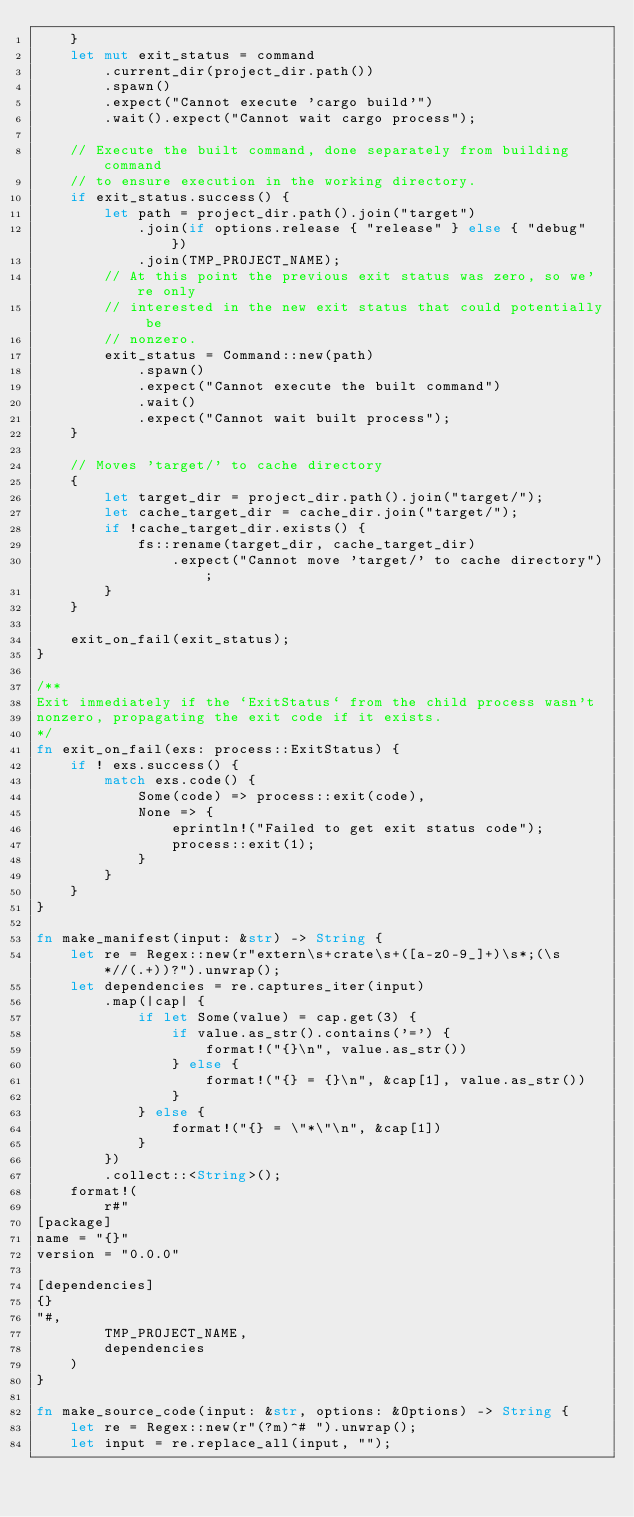Convert code to text. <code><loc_0><loc_0><loc_500><loc_500><_Rust_>    }
    let mut exit_status = command
        .current_dir(project_dir.path())
        .spawn()
        .expect("Cannot execute 'cargo build'")
        .wait().expect("Cannot wait cargo process");

    // Execute the built command, done separately from building command
    // to ensure execution in the working directory.
    if exit_status.success() {
        let path = project_dir.path().join("target")
            .join(if options.release { "release" } else { "debug" })
            .join(TMP_PROJECT_NAME);
        // At this point the previous exit status was zero, so we're only
        // interested in the new exit status that could potentially be
        // nonzero.
        exit_status = Command::new(path)
            .spawn()
            .expect("Cannot execute the built command")
            .wait()
            .expect("Cannot wait built process");
    }

    // Moves 'target/' to cache directory
    {
        let target_dir = project_dir.path().join("target/");
        let cache_target_dir = cache_dir.join("target/");
        if !cache_target_dir.exists() {
            fs::rename(target_dir, cache_target_dir)
                .expect("Cannot move 'target/' to cache directory");
        }
    }

    exit_on_fail(exit_status);
}

/**
Exit immediately if the `ExitStatus` from the child process wasn't
nonzero, propagating the exit code if it exists.
*/
fn exit_on_fail(exs: process::ExitStatus) {
    if ! exs.success() {
        match exs.code() {
            Some(code) => process::exit(code),
            None => {
                eprintln!("Failed to get exit status code");
                process::exit(1);
            }
        }
    }
}

fn make_manifest(input: &str) -> String {
    let re = Regex::new(r"extern\s+crate\s+([a-z0-9_]+)\s*;(\s*//(.+))?").unwrap();
    let dependencies = re.captures_iter(input)
        .map(|cap| {
            if let Some(value) = cap.get(3) {
                if value.as_str().contains('=') {
                    format!("{}\n", value.as_str())
                } else {
                    format!("{} = {}\n", &cap[1], value.as_str())
                }
            } else {
                format!("{} = \"*\"\n", &cap[1])
            }
        })
        .collect::<String>();
    format!(
        r#"
[package]
name = "{}"
version = "0.0.0"

[dependencies]
{}
"#,
        TMP_PROJECT_NAME,
        dependencies
    )
}

fn make_source_code(input: &str, options: &Options) -> String {
    let re = Regex::new(r"(?m)^# ").unwrap();
    let input = re.replace_all(input, "");
</code> 